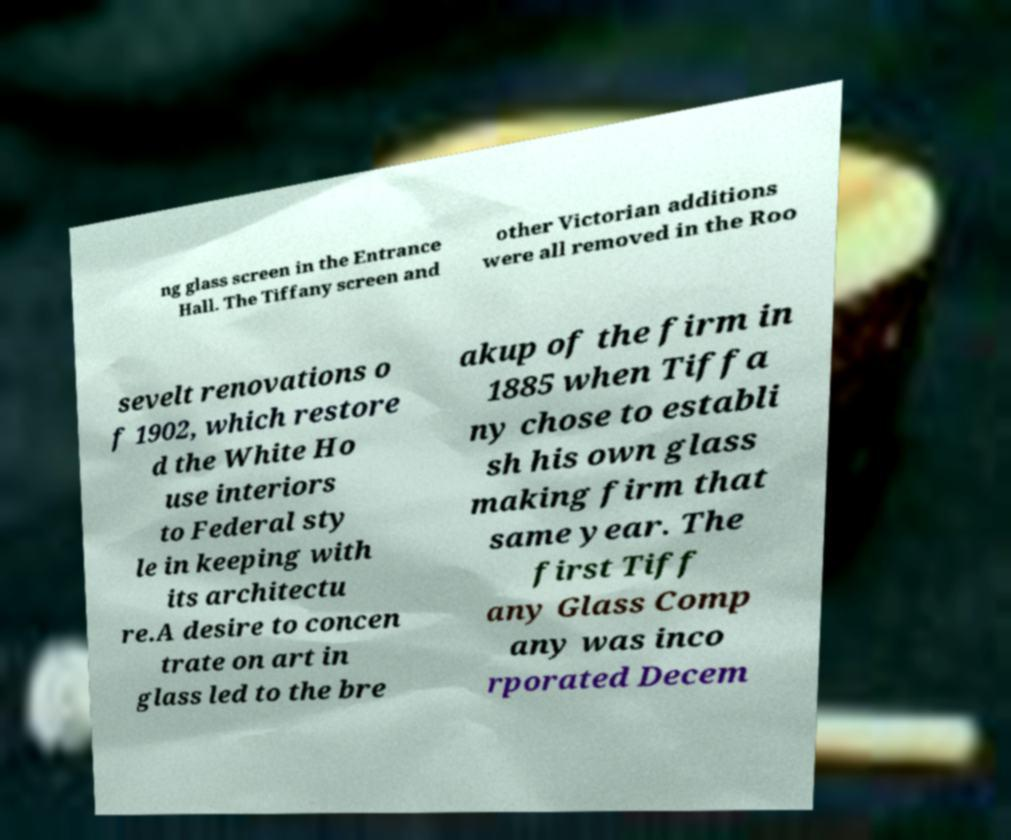There's text embedded in this image that I need extracted. Can you transcribe it verbatim? ng glass screen in the Entrance Hall. The Tiffany screen and other Victorian additions were all removed in the Roo sevelt renovations o f 1902, which restore d the White Ho use interiors to Federal sty le in keeping with its architectu re.A desire to concen trate on art in glass led to the bre akup of the firm in 1885 when Tiffa ny chose to establi sh his own glass making firm that same year. The first Tiff any Glass Comp any was inco rporated Decem 